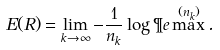<formula> <loc_0><loc_0><loc_500><loc_500>E ( R ) = \lim _ { k \to \infty } - \frac { 1 } { n _ { k } } \log \P e \max ^ { ( n _ { k } ) } .</formula> 